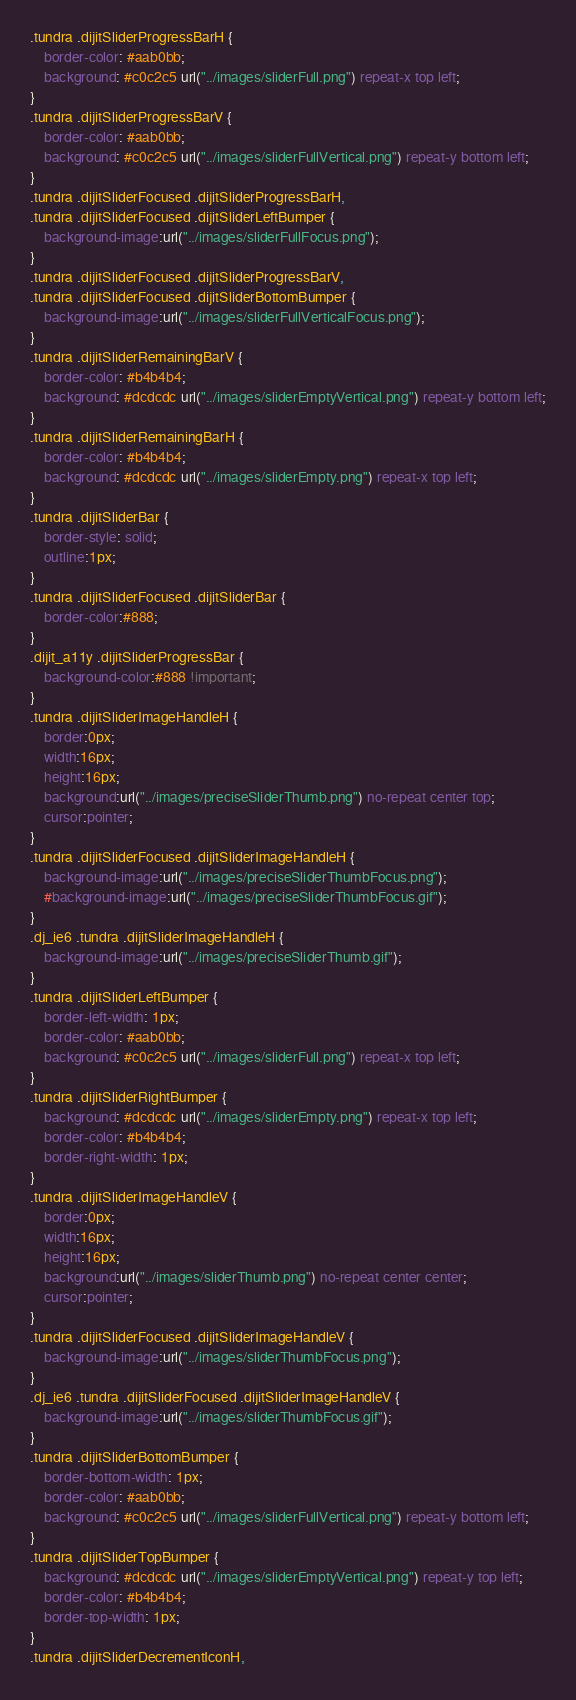<code> <loc_0><loc_0><loc_500><loc_500><_CSS_>.tundra .dijitSliderProgressBarH {
	border-color: #aab0bb;
	background: #c0c2c5 url("../images/sliderFull.png") repeat-x top left;
}
.tundra .dijitSliderProgressBarV {
	border-color: #aab0bb;
	background: #c0c2c5 url("../images/sliderFullVertical.png") repeat-y bottom left;
}
.tundra .dijitSliderFocused .dijitSliderProgressBarH,
.tundra .dijitSliderFocused .dijitSliderLeftBumper {
	background-image:url("../images/sliderFullFocus.png");
}
.tundra .dijitSliderFocused .dijitSliderProgressBarV,
.tundra .dijitSliderFocused .dijitSliderBottomBumper {
	background-image:url("../images/sliderFullVerticalFocus.png");
}
.tundra .dijitSliderRemainingBarV {
	border-color: #b4b4b4;
	background: #dcdcdc url("../images/sliderEmptyVertical.png") repeat-y bottom left;
}
.tundra .dijitSliderRemainingBarH {
	border-color: #b4b4b4;
	background: #dcdcdc url("../images/sliderEmpty.png") repeat-x top left;
}
.tundra .dijitSliderBar {
	border-style: solid;
	outline:1px;
}
.tundra .dijitSliderFocused .dijitSliderBar {
	border-color:#888;	
}
.dijit_a11y .dijitSliderProgressBar {
	background-color:#888 !important;
}
.tundra .dijitSliderImageHandleH {
	border:0px;
	width:16px;
	height:16px;
	background:url("../images/preciseSliderThumb.png") no-repeat center top;
	cursor:pointer;
}
.tundra .dijitSliderFocused .dijitSliderImageHandleH {
	background-image:url("../images/preciseSliderThumbFocus.png");
	#background-image:url("../images/preciseSliderThumbFocus.gif");
}
.dj_ie6 .tundra .dijitSliderImageHandleH {
	background-image:url("../images/preciseSliderThumb.gif");
}
.tundra .dijitSliderLeftBumper {
	border-left-width: 1px;
	border-color: #aab0bb;
	background: #c0c2c5 url("../images/sliderFull.png") repeat-x top left;
}
.tundra .dijitSliderRightBumper {
	background: #dcdcdc url("../images/sliderEmpty.png") repeat-x top left;
	border-color: #b4b4b4;
	border-right-width: 1px;
}
.tundra .dijitSliderImageHandleV {
	border:0px;
	width:16px;
	height:16px;
	background:url("../images/sliderThumb.png") no-repeat center center;
	cursor:pointer;
}
.tundra .dijitSliderFocused .dijitSliderImageHandleV {
	background-image:url("../images/sliderThumbFocus.png");
}
.dj_ie6 .tundra .dijitSliderFocused .dijitSliderImageHandleV {
	background-image:url("../images/sliderThumbFocus.gif");
}
.tundra .dijitSliderBottomBumper {
	border-bottom-width: 1px;
	border-color: #aab0bb;
	background: #c0c2c5 url("../images/sliderFullVertical.png") repeat-y bottom left;
}
.tundra .dijitSliderTopBumper {
	background: #dcdcdc url("../images/sliderEmptyVertical.png") repeat-y top left;
	border-color: #b4b4b4;
	border-top-width: 1px;
}
.tundra .dijitSliderDecrementIconH,</code> 